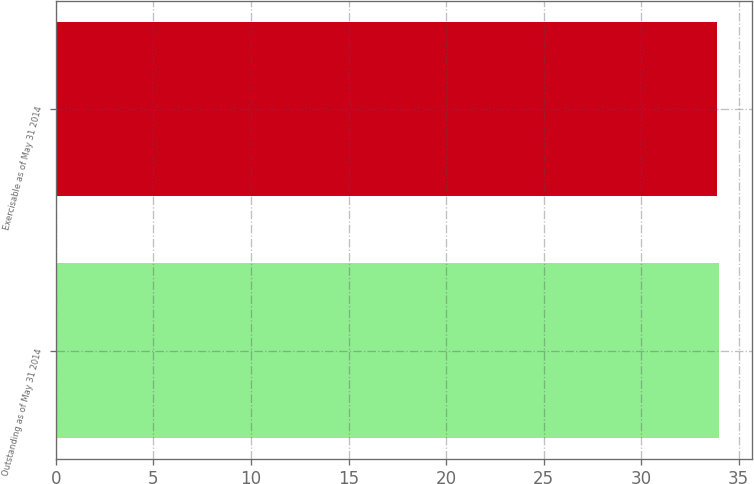Convert chart to OTSL. <chart><loc_0><loc_0><loc_500><loc_500><bar_chart><fcel>Outstanding as of May 31 2014<fcel>Exercisable as of May 31 2014<nl><fcel>34<fcel>33.87<nl></chart> 